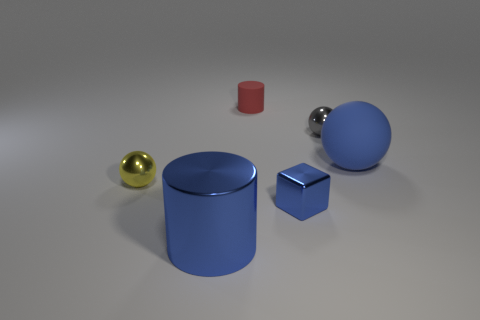Add 2 gray balls. How many objects exist? 8 Subtract all cylinders. How many objects are left? 4 Add 4 tiny red matte objects. How many tiny red matte objects exist? 5 Subtract 0 brown cylinders. How many objects are left? 6 Subtract all tiny yellow shiny things. Subtract all blue rubber spheres. How many objects are left? 4 Add 6 big cylinders. How many big cylinders are left? 7 